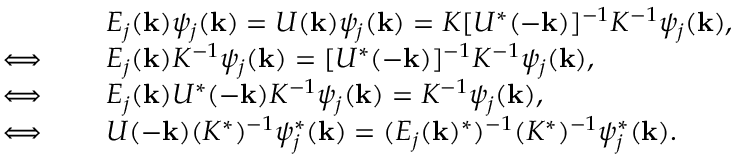<formula> <loc_0><loc_0><loc_500><loc_500>\begin{array} { r l } & { E _ { j } ( { k } ) \psi _ { j } ( { k } ) = U ( { k } ) \psi _ { j } ( { k } ) = K [ U ^ { * } ( - { k } ) ] ^ { - 1 } K ^ { - 1 } \psi _ { j } ( { k } ) , } \\ { \iff \quad } & { E _ { j } ( { k } ) K ^ { - 1 } \psi _ { j } ( { k } ) = [ U ^ { * } ( - { k } ) ] ^ { - 1 } K ^ { - 1 } \psi _ { j } ( { k } ) , } \\ { \iff \quad } & { E _ { j } ( { k } ) U ^ { * } ( - { k } ) K ^ { - 1 } \psi _ { j } ( { k } ) = K ^ { - 1 } \psi _ { j } ( { k } ) , } \\ { \iff \quad } & { U ( - { k } ) ( K ^ { * } ) ^ { - 1 } \psi _ { j } ^ { * } ( { k } ) = ( E _ { j } ( { k } ) ^ { * } ) ^ { - 1 } ( K ^ { * } ) ^ { - 1 } \psi _ { j } ^ { * } ( { k } ) . } \end{array}</formula> 